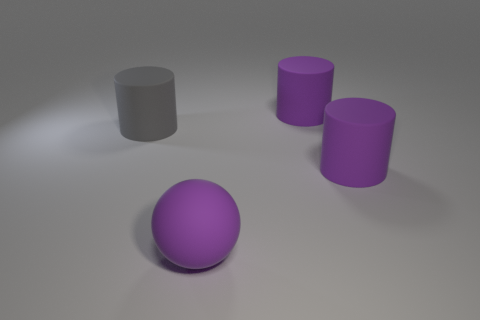Add 1 big purple cylinders. How many objects exist? 5 Subtract all spheres. How many objects are left? 3 Subtract all big gray matte things. Subtract all large spheres. How many objects are left? 2 Add 4 gray rubber cylinders. How many gray rubber cylinders are left? 5 Add 2 rubber spheres. How many rubber spheres exist? 3 Subtract 0 cyan spheres. How many objects are left? 4 